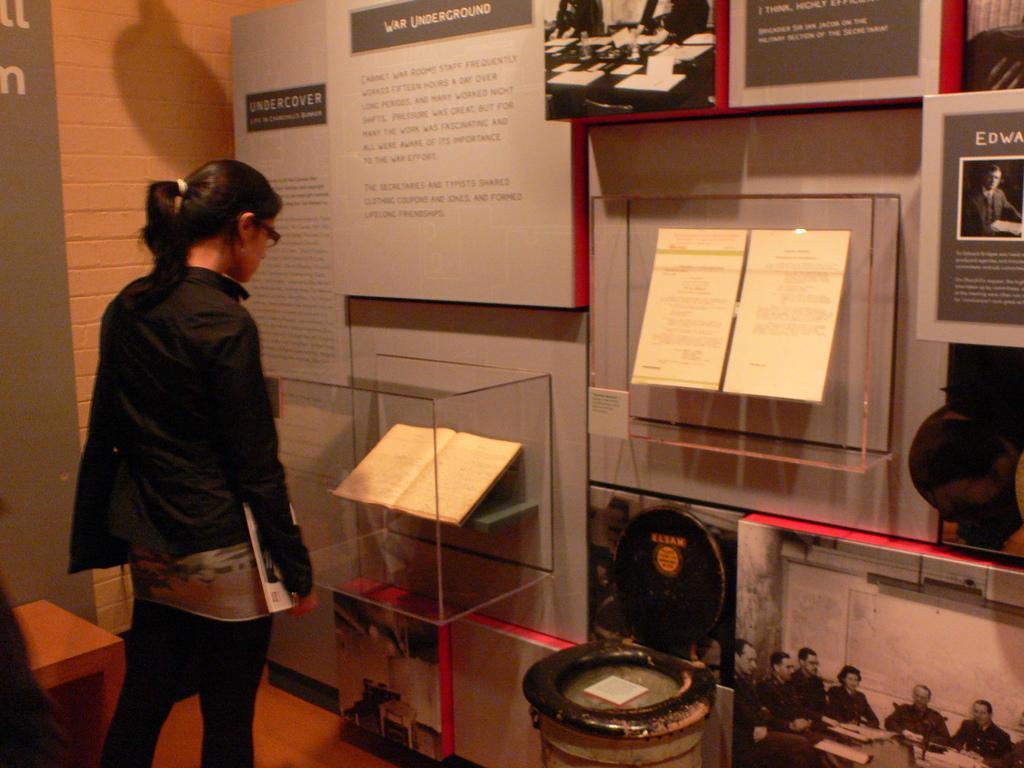Can you describe this image briefly? A woman is standing and looking at the book. She is holding a book in her hand. On the wall we can see posters. 